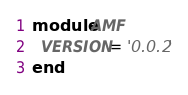<code> <loc_0><loc_0><loc_500><loc_500><_Ruby_>module AMF
  VERSION = '0.0.2'
end
</code> 